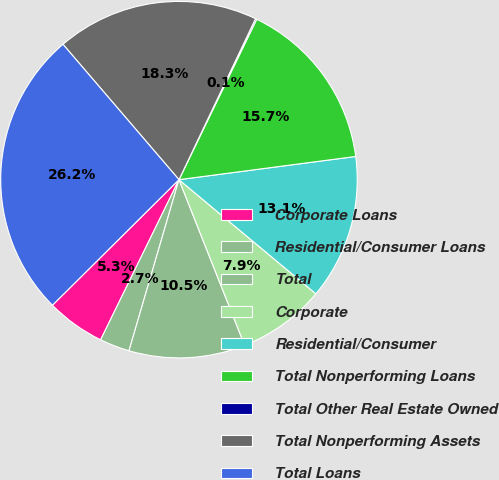Convert chart to OTSL. <chart><loc_0><loc_0><loc_500><loc_500><pie_chart><fcel>Corporate Loans<fcel>Residential/Consumer Loans<fcel>Total<fcel>Corporate<fcel>Residential/Consumer<fcel>Total Nonperforming Loans<fcel>Total Other Real Estate Owned<fcel>Total Nonperforming Assets<fcel>Total Loans<nl><fcel>5.32%<fcel>2.72%<fcel>10.53%<fcel>7.93%<fcel>13.14%<fcel>15.74%<fcel>0.12%<fcel>18.34%<fcel>26.16%<nl></chart> 